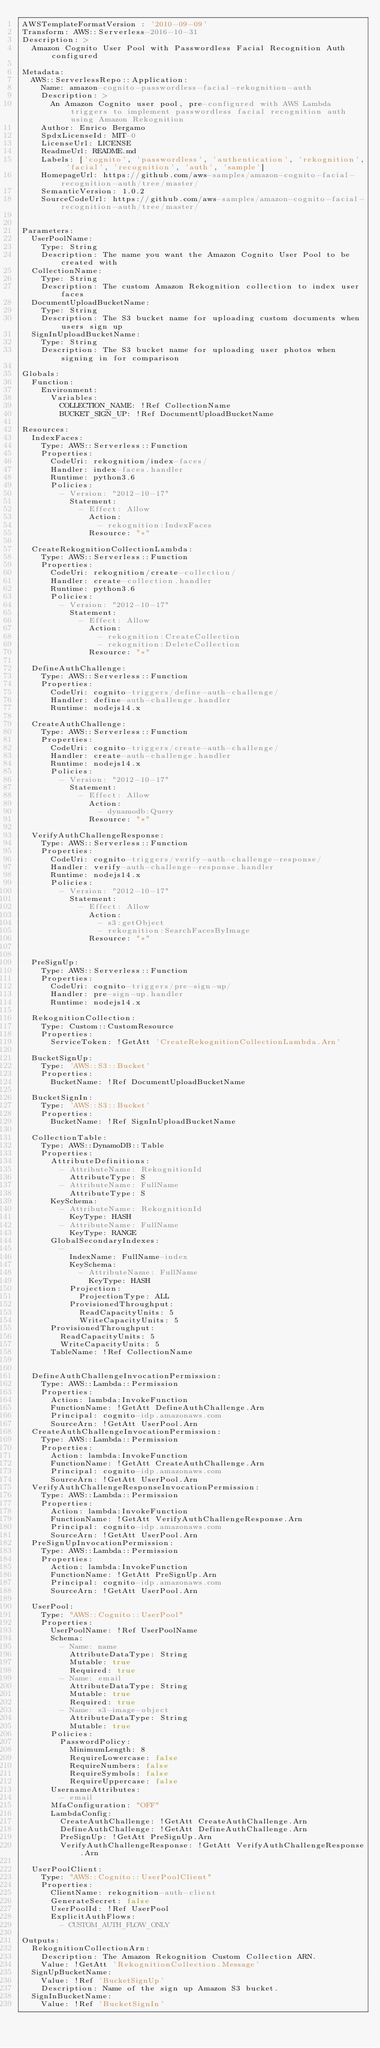Convert code to text. <code><loc_0><loc_0><loc_500><loc_500><_YAML_>AWSTemplateFormatVersion : '2010-09-09'
Transform: AWS::Serverless-2016-10-31
Description: >
  Amazon Cognito User Pool with Passwordless Facial Recognition Auth configured

Metadata:
  AWS::ServerlessRepo::Application:
    Name: amazon-cognito-passwordless-facial-rekognition-auth
    Description: >
      An Amazon Cognito user pool, pre-configured with AWS Lambda triggers to implement passwordless facial recognition auth using Amazon Rekognition
    Author: Enrico Bergamo
    SpdxLicenseId: MIT-0
    LicenseUrl: LICENSE
    ReadmeUrl: README.md
    Labels: ['cognito', 'passwordless', 'authentication', 'rekognition', 'facial', 'recognition', 'auth', 'sample']
    HomepageUrl: https://github.com/aws-samples/amazon-cognito-facial-recognition-auth/tree/master/
    SemanticVersion: 1.0.2
    SourceCodeUrl: https://github.com/aws-samples/amazon-cognito-facial-recognition-auth/tree/master/


Parameters:
  UserPoolName:
    Type: String
    Description: The name you want the Amazon Cognito User Pool to be created with
  CollectionName:
    Type: String
    Description: The custom Amazon Rekognition collection to index user faces
  DocumentUploadBucketName:
    Type: String
    Description: The S3 bucket name for uploading custom documents when users sign up
  SignInUploadBucketName:
    Type: String
    Description: The S3 bucket name for uploading user photos when signing in for comparison

Globals:
  Function:
    Environment:
      Variables:
        COLLECTION_NAME: !Ref CollectionName
        BUCKET_SIGN_UP: !Ref DocumentUploadBucketName

Resources:
  IndexFaces:
    Type: AWS::Serverless::Function
    Properties:
      CodeUri: rekognition/index-faces/
      Handler: index-faces.handler
      Runtime: python3.6
      Policies:
        - Version: "2012-10-17"
          Statement:
            - Effect: Allow
              Action:
                - rekognition:IndexFaces
              Resource: "*"

  CreateRekognitionCollectionLambda:
    Type: AWS::Serverless::Function
    Properties:
      CodeUri: rekognition/create-collection/
      Handler: create-collection.handler
      Runtime: python3.6
      Policies:
        - Version: "2012-10-17"
          Statement:
            - Effect: Allow
              Action:
                - rekognition:CreateCollection
                - rekognition:DeleteCollection
              Resource: "*"

  DefineAuthChallenge:
    Type: AWS::Serverless::Function
    Properties:
      CodeUri: cognito-triggers/define-auth-challenge/
      Handler: define-auth-challenge.handler
      Runtime: nodejs14.x

  CreateAuthChallenge:
    Type: AWS::Serverless::Function
    Properties:
      CodeUri: cognito-triggers/create-auth-challenge/
      Handler: create-auth-challenge.handler
      Runtime: nodejs14.x
      Policies:
        - Version: "2012-10-17"
          Statement:
            - Effect: Allow
              Action:
                - dynamodb:Query
              Resource: "*"

  VerifyAuthChallengeResponse:
    Type: AWS::Serverless::Function
    Properties:
      CodeUri: cognito-triggers/verify-auth-challenge-response/
      Handler: verify-auth-challenge-response.handler
      Runtime: nodejs14.x
      Policies:
        - Version: "2012-10-17"
          Statement:
            - Effect: Allow
              Action:
                - s3:getObject
                - rekognition:SearchFacesByImage
              Resource: "*"
      

  PreSignUp:
    Type: AWS::Serverless::Function
    Properties:
      CodeUri: cognito-triggers/pre-sign-up/
      Handler: pre-sign-up.handler
      Runtime: nodejs14.x
  
  RekognitionCollection:
    Type: Custom::CustomResource
    Properties:
      ServiceToken: !GetAtt 'CreateRekognitionCollectionLambda.Arn'

  BucketSignUp:
    Type: 'AWS::S3::Bucket'
    Properties:
      BucketName: !Ref DocumentUploadBucketName    

  BucketSignIn:
    Type: 'AWS::S3::Bucket'
    Properties:
      BucketName: !Ref SignInUploadBucketName 

  CollectionTable:
    Type: AWS::DynamoDB::Table
    Properties: 
      AttributeDefinitions: 
        - AttributeName: RekognitionId
          AttributeType: S
        - AttributeName: FullName
          AttributeType: S
      KeySchema: 
        - AttributeName: RekognitionId
          KeyType: HASH
        - AttributeName: FullName
          KeyType: RANGE
      GlobalSecondaryIndexes: 
        - 
          IndexName: FullName-index
          KeySchema: 
            - AttributeName: FullName
              KeyType: HASH
          Projection: 
            ProjectionType: ALL
          ProvisionedThroughput: 
            ReadCapacityUnits: 5
            WriteCapacityUnits: 5
      ProvisionedThroughput: 
        ReadCapacityUnits: 5
        WriteCapacityUnits: 5
      TableName: !Ref CollectionName


  DefineAuthChallengeInvocationPermission:
    Type: AWS::Lambda::Permission
    Properties:
      Action: lambda:InvokeFunction
      FunctionName: !GetAtt DefineAuthChallenge.Arn
      Principal: cognito-idp.amazonaws.com
      SourceArn: !GetAtt UserPool.Arn
  CreateAuthChallengeInvocationPermission:
    Type: AWS::Lambda::Permission
    Properties:
      Action: lambda:InvokeFunction
      FunctionName: !GetAtt CreateAuthChallenge.Arn
      Principal: cognito-idp.amazonaws.com
      SourceArn: !GetAtt UserPool.Arn
  VerifyAuthChallengeResponseInvocationPermission:
    Type: AWS::Lambda::Permission
    Properties:
      Action: lambda:InvokeFunction
      FunctionName: !GetAtt VerifyAuthChallengeResponse.Arn
      Principal: cognito-idp.amazonaws.com
      SourceArn: !GetAtt UserPool.Arn
  PreSignUpInvocationPermission:
    Type: AWS::Lambda::Permission
    Properties:
      Action: lambda:InvokeFunction
      FunctionName: !GetAtt PreSignUp.Arn
      Principal: cognito-idp.amazonaws.com
      SourceArn: !GetAtt UserPool.Arn

  UserPool:
    Type: "AWS::Cognito::UserPool"
    Properties:
      UserPoolName: !Ref UserPoolName
      Schema:
        - Name: name
          AttributeDataType: String
          Mutable: true
          Required: true
        - Name: email
          AttributeDataType: String
          Mutable: true
          Required: true
        - Name: s3-image-object
          AttributeDataType: String
          Mutable: true
      Policies:
        PasswordPolicy:
          MinimumLength: 8
          RequireLowercase: false
          RequireNumbers: false
          RequireSymbols: false
          RequireUppercase: false
      UsernameAttributes:
        - email
      MfaConfiguration: "OFF"
      LambdaConfig:
        CreateAuthChallenge: !GetAtt CreateAuthChallenge.Arn
        DefineAuthChallenge: !GetAtt DefineAuthChallenge.Arn
        PreSignUp: !GetAtt PreSignUp.Arn
        VerifyAuthChallengeResponse: !GetAtt VerifyAuthChallengeResponse.Arn

  UserPoolClient:
    Type: "AWS::Cognito::UserPoolClient"
    Properties:
      ClientName: rekognition-auth-client
      GenerateSecret: false
      UserPoolId: !Ref UserPool
      ExplicitAuthFlows:
        - CUSTOM_AUTH_FLOW_ONLY

Outputs:
  RekognitionCollectionArn:
    Description: The Amazon Rekognition Custom Collection ARN.
    Value: !GetAtt 'RekognitionCollection.Message'
  SignUpBucketName:
    Value: !Ref 'BucketSignUp'
    Description: Name of the sign up Amazon S3 bucket.
  SignInBucketName:
    Value: !Ref 'BucketSignIn'</code> 